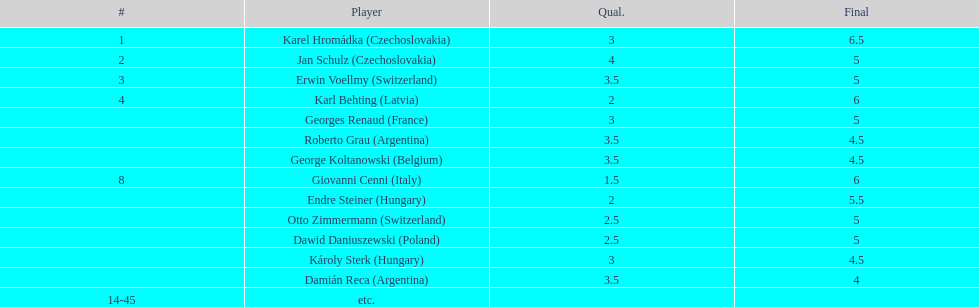How many players had a 8 points? 4. 